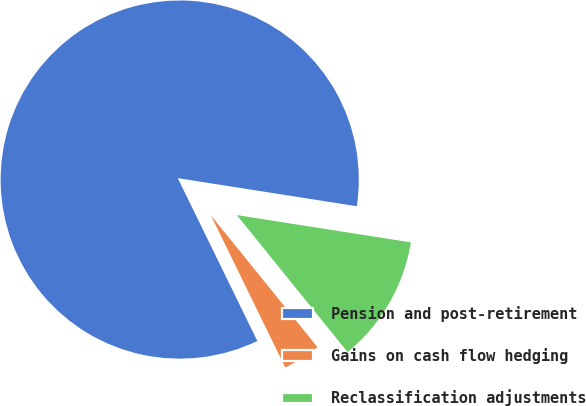Convert chart. <chart><loc_0><loc_0><loc_500><loc_500><pie_chart><fcel>Pension and post-retirement<fcel>Gains on cash flow hedging<fcel>Reclassification adjustments<nl><fcel>84.71%<fcel>3.59%<fcel>11.7%<nl></chart> 